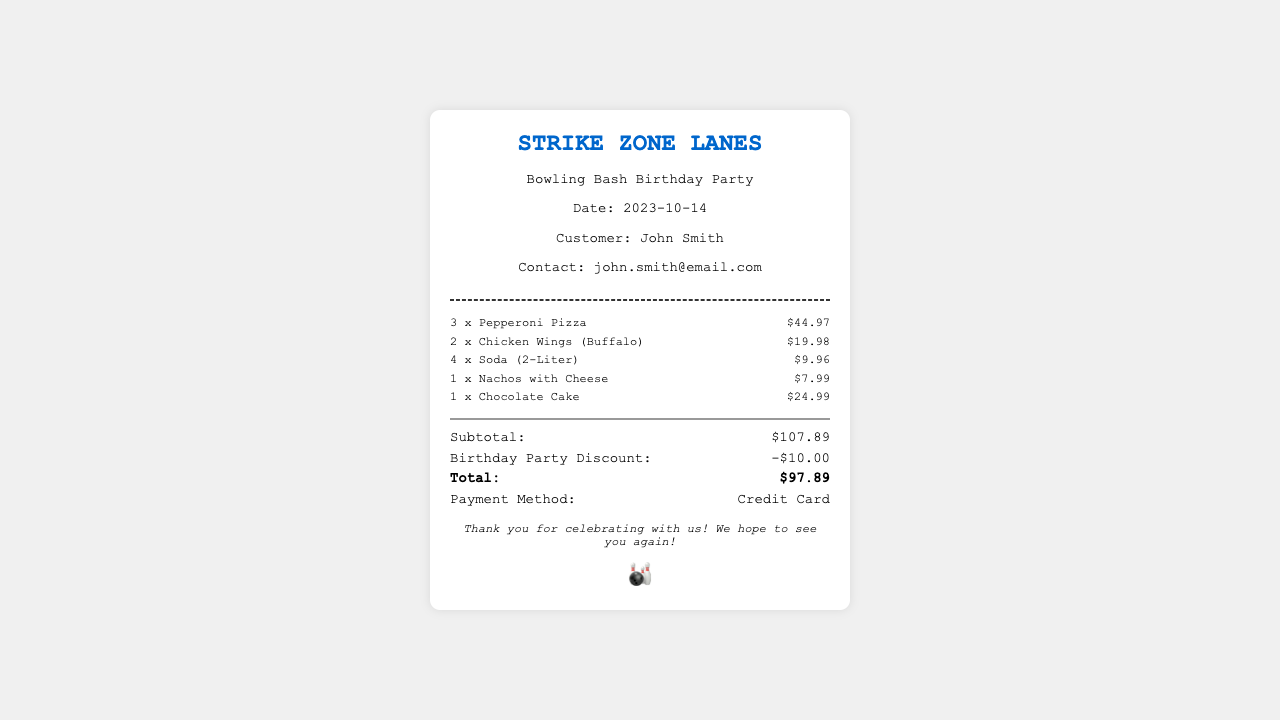what is the customer name? The customer's name is provided in the receipt under the "Customer" section, which is John Smith.
Answer: John Smith what is the total amount after discount? The total amount after the birthday party discount is shown clearly in the totals section of the receipt, marked as "Total," which is $97.89.
Answer: $97.89 how many Pepperoni Pizzas were ordered? The number of Pepperoni Pizzas ordered is displayed next to the item name in the receipt, which is 3.
Answer: 3 what was the amount of the birthday party discount? The discount given for the birthday party is detailed in the totals section, showing a deduction of $10.00.
Answer: -$10.00 what is the payment method used? The payment method is indicated in the totals section of the receipt, which states "Payment Method" as Credit Card.
Answer: Credit Card how many items are listed in the order? The order contains a list of items that can be counted from the menu section of the receipt, which shows a total of 5 items.
Answer: 5 what type of event is this receipt for? The event type is mentioned in the header of the receipt, which states it is a Birthday Party.
Answer: Birthday Party what is the subtotal amount before discounts? The subtotal amount before applying any discounts is indicated in the totals section as $107.89.
Answer: $107.89 what is the date of the event? The date of the event is provided in the event information section, which is October 14, 2023.
Answer: 2023-10-14 